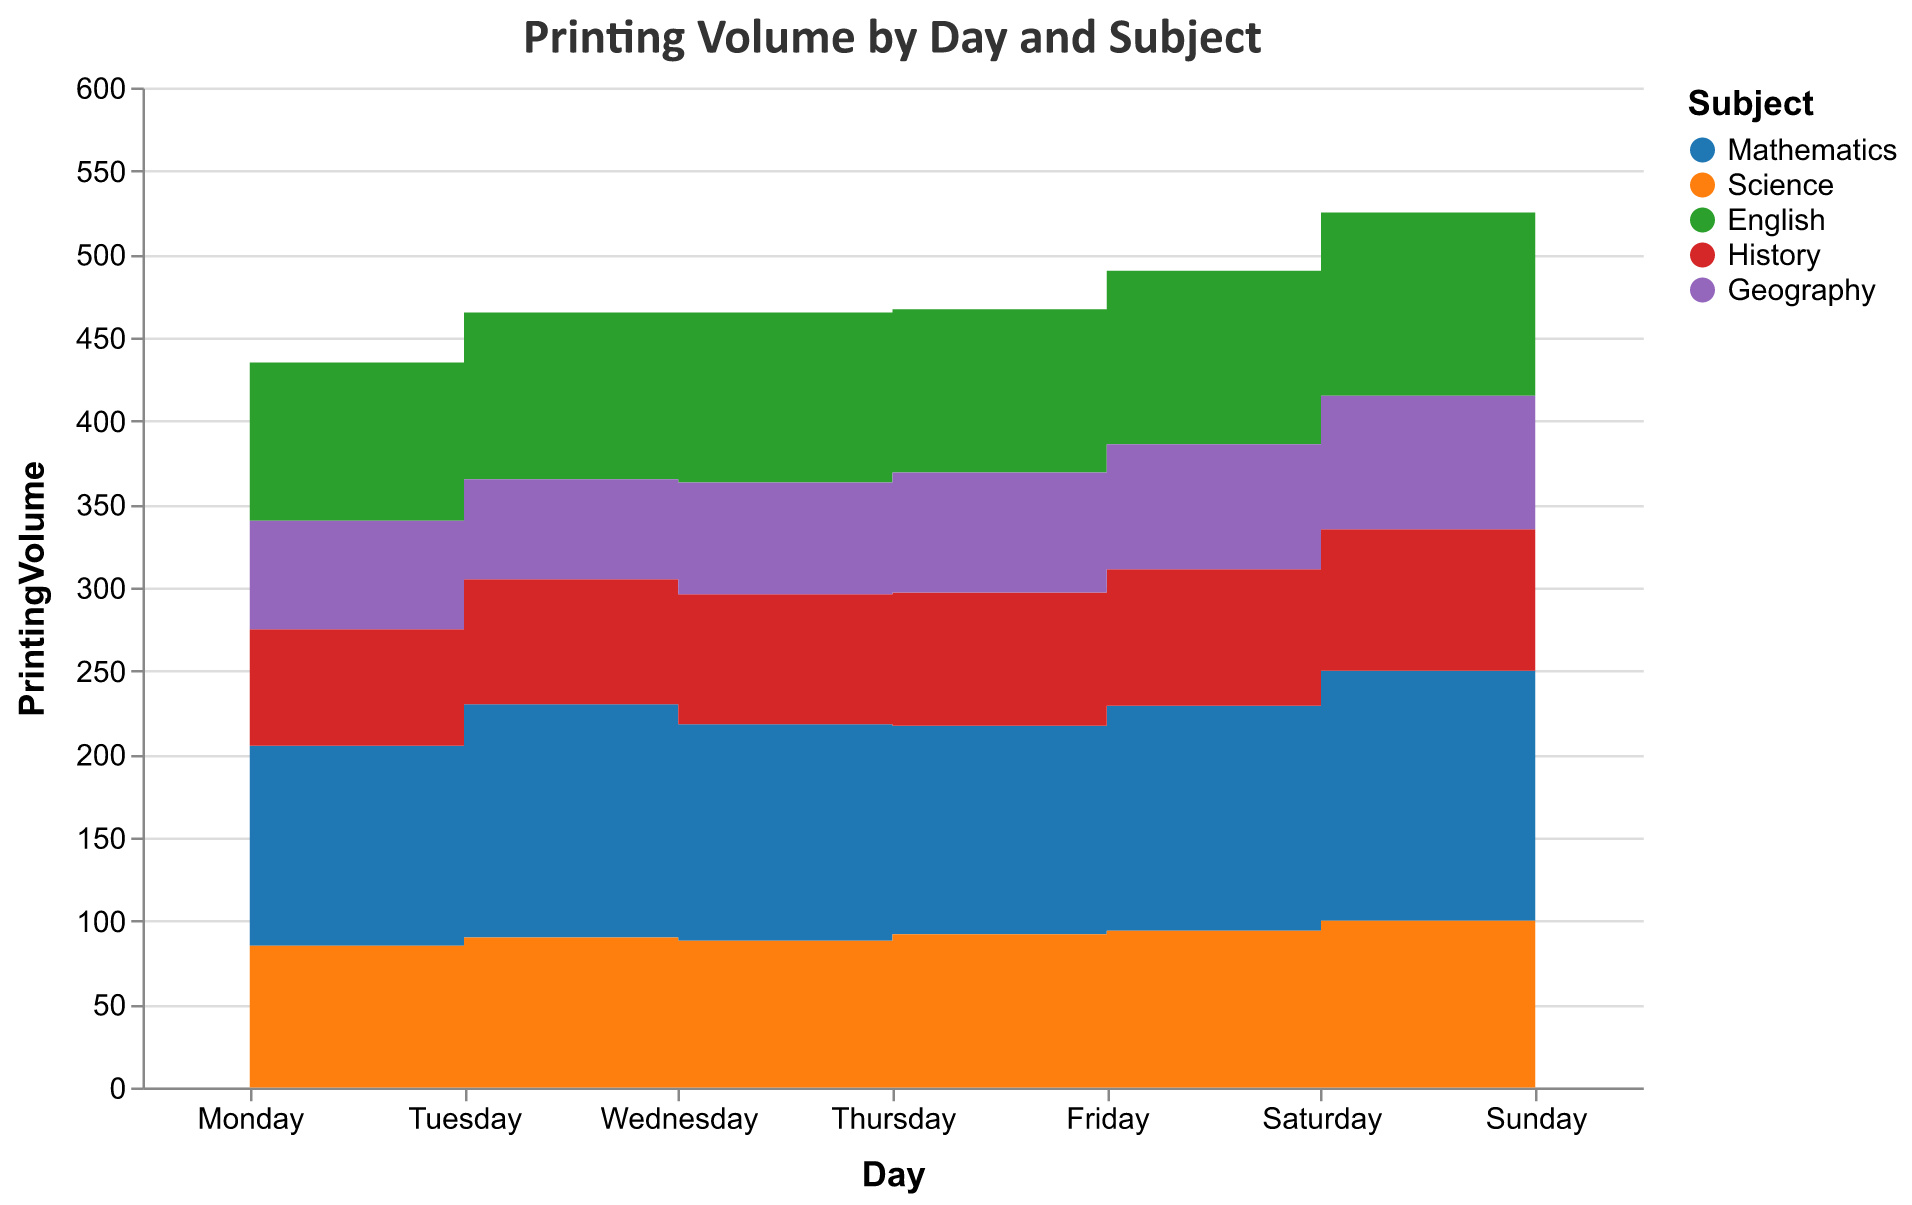What is the title of the figure? The title of the figure is positioned at the top and it reads "Printing Volume by Day and Subject"
Answer: Printing Volume by Day and Subject Which subject has the highest printing volume on Sunday? Look at the segments representing each subject on the 'Sunday' column. The tallest segment indicates the highest volume, which is for Mathematics
Answer: Mathematics How does the printing volume of Geography on Monday compare to that on Friday? On Monday, the printing volume for Geography is 65 and on Friday it is 75. Therefore, the volume increases from Monday to Friday
Answer: It increases What is the total printing volume for all subjects on Wednesday? Add the printing volumes of all subjects on Wednesday: 130 (Mathematics) + 88 (Science) + 102 (English) + 78 (History) + 67 (Geography)
Answer: 465 Which day has the lowest cumulative printing volume across all subjects? Sum up the printing volumes for each day and compare: Monday: 120+85+95+70+65=435, Tuesday: 140+90+100+75+60=465, Wednesday: 130+88+102+78+67=465, etc. Tuesday has a cumulative volume of 465 which is the highest, and Monday has the lowest
Answer: Monday On which day does the printing volume of Science surpass 100? Observing the 'Science' volumes on each day: It surpasses 100 only on Saturday (100) and Sunday (105)
Answer: Sunday What is the average printing volume for Mathematics over the week? The volumes for Mathematics throughout the week are: 120, 140, 130, 125, 135, 150, 160. The average is calculated as (120+140+130+125+135+150+160)/7
Answer: 137.14 By how much does the printing volume for English change from Monday to Friday? The English volumes on Monday and Friday are 95 and 104, respectively. The change is calculated as 104 - 95
Answer: 9 Which subject shows a steady increase in printing volume from Monday to Sunday? By tracing the volumes for each subject day by day, it can be observed that Mathematics shows a steady increase each day from Monday (120) to Sunday (160)
Answer: Mathematics What is the difference in printing volume for History between Thursday and Saturday? The History volumes on Thursday and Saturday are 80 and 85, respectively. The difference is calculated as 85 - 80
Answer: 5 